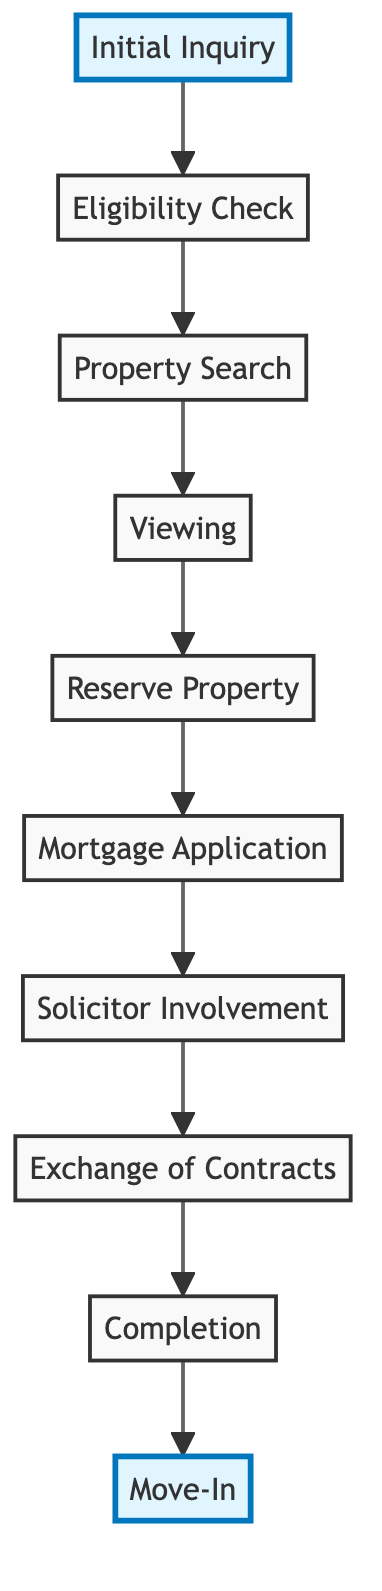What is the first step in the Shared Ownership application process? The first step in the application process is indicated in the diagram as "Initial Inquiry." This is the starting point where potential buyers begin their journey.
Answer: Initial Inquiry How many total steps are depicted in the Shared Ownership process? By counting each node in the diagram from "Initial Inquiry" to "Move-In," we find there are ten distinct steps in the shared ownership application process.
Answer: 10 What step follows the "Property Search"? Looking at the diagram, "Viewing" comes directly after "Property Search." This indicates that once the buyer identifies potential properties, they will then proceed to view them.
Answer: Viewing Which step involves a financial application? The diagram shows that "Mortgage Application" is the step related to financial dealings, indicating the process where the buyer applies for a mortgage to fund their purchase.
Answer: Mortgage Application What is the last step that occurs before the buyer moves into the property? The step right before "Move-In" in the diagram is "Completion," which shows that this is the final stage of securing the property before actually moving in.
Answer: Completion What type of check is conducted after the "Initial Inquiry"? Per the diagram, the step that follows "Initial Inquiry" is "Eligibility Check," which means that a screening or assessment occurs immediately after the first inquiry to determine suitability.
Answer: Eligibility Check What action takes place after "Reserve Property"? According to the diagram, once a buyer reserves a property, the next action is to proceed to the "Mortgage Application." This indicates the financial formalities that follow property reservation.
Answer: Mortgage Application How many distinct types of actions are listed in the steps? The actions can be divided into different types such as inquiry, application, viewing, and moving phases. Counting the distinct actions depicted leads to categorizing them accordingly, and there are eight distinct types of actions represented in the diagram.
Answer: 8 What happens before the "Exchange of Contracts"? The diagram states that "Solicitor Involvement" occurs right before "Exchange of Contracts." This shows the legal process that must be completed prior to finalizing the agreement.
Answer: Solicitor Involvement 